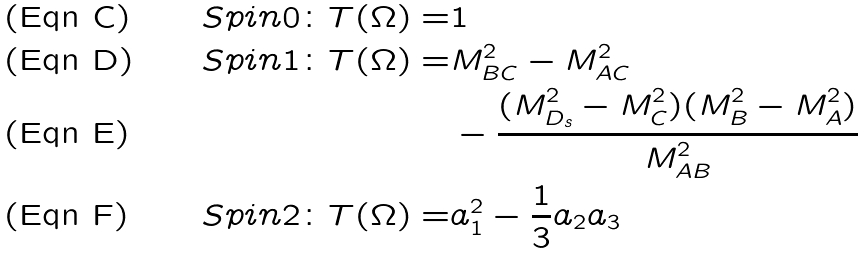<formula> <loc_0><loc_0><loc_500><loc_500>S p i n 0 \colon T ( \Omega ) = & 1 \\ S p i n 1 \colon T ( \Omega ) = & M ^ { 2 } _ { B C } - M ^ { 2 } _ { A C } \\ & - \frac { ( M ^ { 2 } _ { D _ { s } } - M ^ { 2 } _ { C } ) ( M ^ { 2 } _ { B } - M ^ { 2 } _ { A } ) } { M _ { A B } ^ { 2 } } \\ S p i n 2 \colon T ( \Omega ) = & a _ { 1 } ^ { 2 } - \frac { 1 } { 3 } a _ { 2 } a _ { 3 }</formula> 